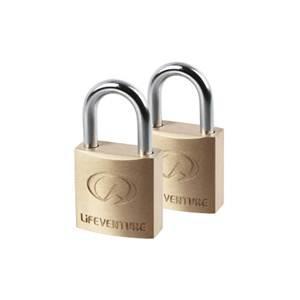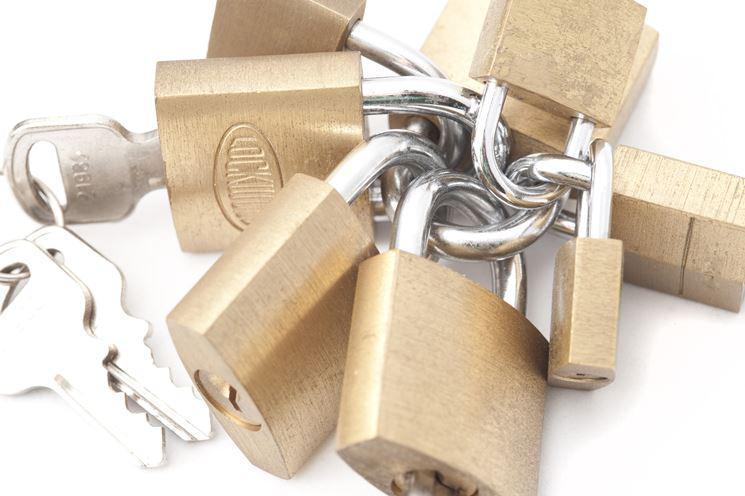The first image is the image on the left, the second image is the image on the right. For the images displayed, is the sentence "There's at least two keys in the right image." factually correct? Answer yes or no. No. The first image is the image on the left, the second image is the image on the right. For the images displayed, is the sentence "An image shows a ring of keys next to, but not attached to, an upright lock." factually correct? Answer yes or no. No. 